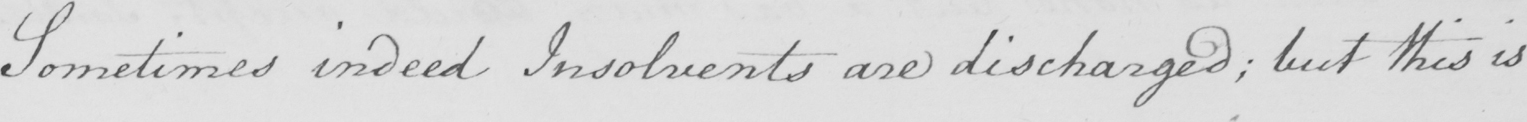Transcribe the text shown in this historical manuscript line. Sometimes indeed Insolvents are discharged ; but this is 